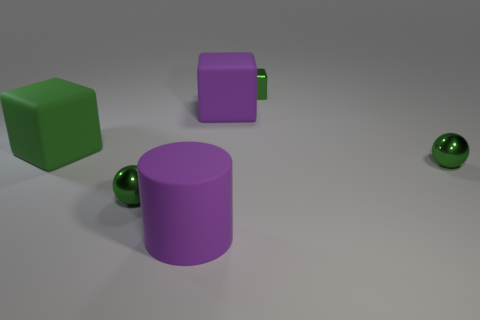Add 4 yellow cylinders. How many objects exist? 10 Subtract all tiny cubes. How many cubes are left? 2 Subtract 2 spheres. How many spheres are left? 0 Subtract all spheres. How many objects are left? 4 Subtract all blue spheres. Subtract all red cubes. How many spheres are left? 2 Subtract all blue balls. How many purple blocks are left? 1 Subtract all small cubes. Subtract all big purple cubes. How many objects are left? 4 Add 6 big purple objects. How many big purple objects are left? 8 Add 4 big green rubber cubes. How many big green rubber cubes exist? 5 Subtract all purple blocks. How many blocks are left? 2 